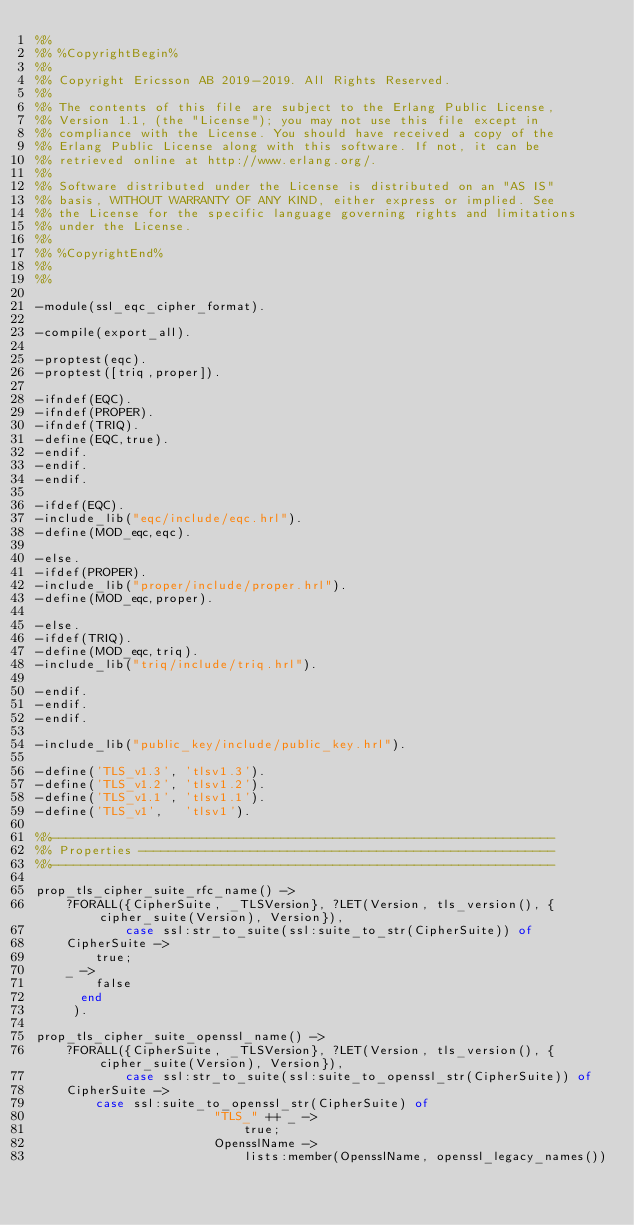<code> <loc_0><loc_0><loc_500><loc_500><_Erlang_>%%
%% %CopyrightBegin%
%% 
%% Copyright Ericsson AB 2019-2019. All Rights Reserved.
%% 
%% The contents of this file are subject to the Erlang Public License,
%% Version 1.1, (the "License"); you may not use this file except in
%% compliance with the License. You should have received a copy of the
%% Erlang Public License along with this software. If not, it can be
%% retrieved online at http://www.erlang.org/.
%% 
%% Software distributed under the License is distributed on an "AS IS"
%% basis, WITHOUT WARRANTY OF ANY KIND, either express or implied. See
%% the License for the specific language governing rights and limitations
%% under the License.
%% 
%% %CopyrightEnd%
%%
%%

-module(ssl_eqc_cipher_format).

-compile(export_all).

-proptest(eqc).
-proptest([triq,proper]).

-ifndef(EQC).
-ifndef(PROPER).
-ifndef(TRIQ).
-define(EQC,true).
-endif.
-endif.
-endif.

-ifdef(EQC).
-include_lib("eqc/include/eqc.hrl").
-define(MOD_eqc,eqc).

-else.
-ifdef(PROPER).
-include_lib("proper/include/proper.hrl").
-define(MOD_eqc,proper).

-else.
-ifdef(TRIQ).
-define(MOD_eqc,triq).
-include_lib("triq/include/triq.hrl").

-endif.
-endif.
-endif.

-include_lib("public_key/include/public_key.hrl").

-define('TLS_v1.3', 'tlsv1.3').
-define('TLS_v1.2', 'tlsv1.2').
-define('TLS_v1.1', 'tlsv1.1').
-define('TLS_v1',   'tlsv1').

%%--------------------------------------------------------------------
%% Properties --------------------------------------------------------
%%--------------------------------------------------------------------

prop_tls_cipher_suite_rfc_name() ->
    ?FORALL({CipherSuite, _TLSVersion}, ?LET(Version, tls_version(), {cipher_suite(Version), Version}),
            case ssl:str_to_suite(ssl:suite_to_str(CipherSuite)) of
		CipherSuite ->
		    true;
		_ ->
		    false
	    end
	   ).

prop_tls_cipher_suite_openssl_name() ->
    ?FORALL({CipherSuite, _TLSVersion}, ?LET(Version, tls_version(), {cipher_suite(Version), Version}),
            case ssl:str_to_suite(ssl:suite_to_openssl_str(CipherSuite)) of
		CipherSuite ->                    
		    case ssl:suite_to_openssl_str(CipherSuite) of
                        "TLS_" ++ _ ->
                            true;
                        OpensslName ->
                            lists:member(OpensslName, openssl_legacy_names())</code> 